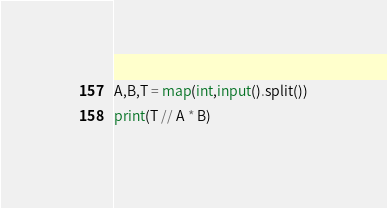<code> <loc_0><loc_0><loc_500><loc_500><_Python_>A,B,T = map(int,input().split())
print(T // A * B)</code> 